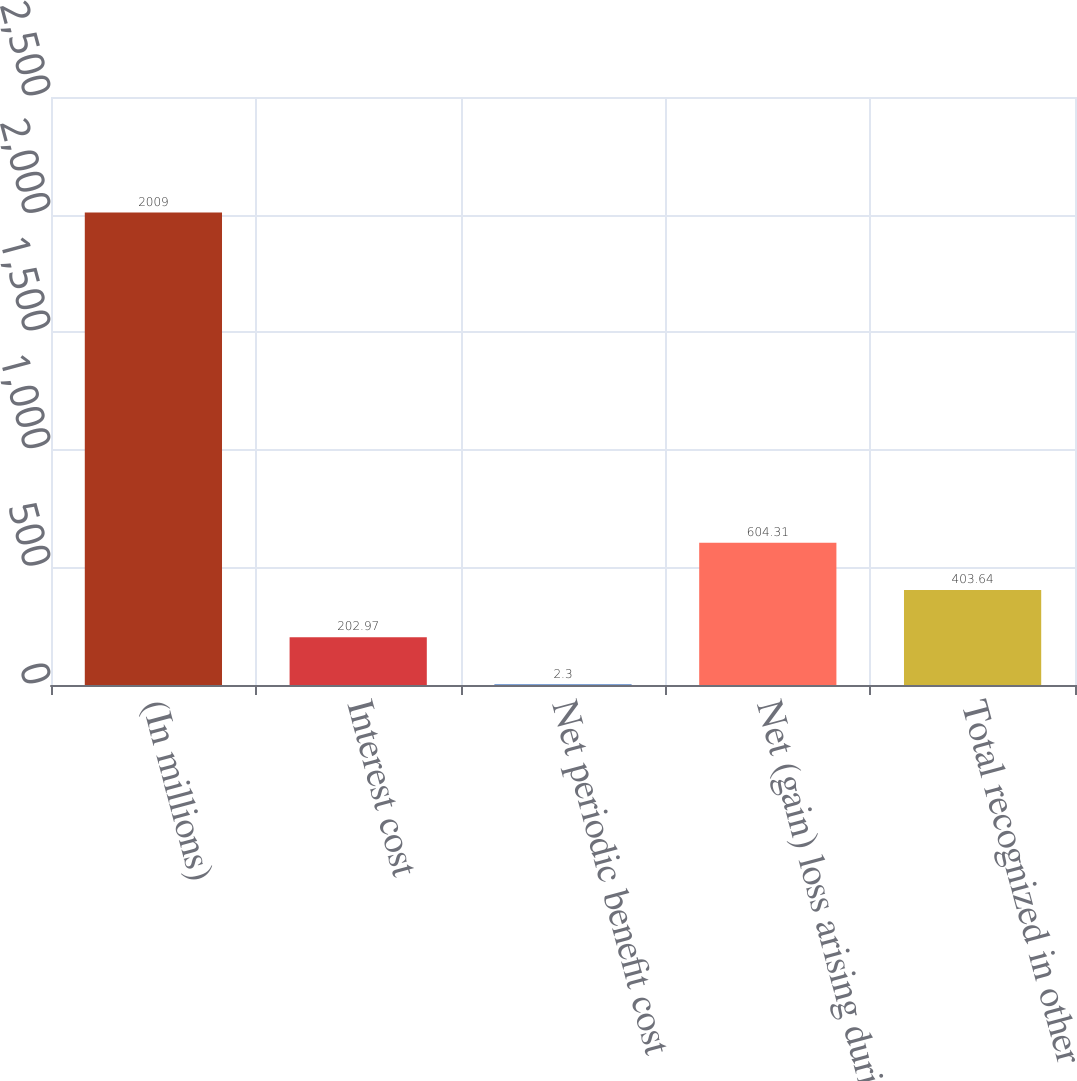Convert chart to OTSL. <chart><loc_0><loc_0><loc_500><loc_500><bar_chart><fcel>(In millions)<fcel>Interest cost<fcel>Net periodic benefit cost<fcel>Net (gain) loss arising during<fcel>Total recognized in other<nl><fcel>2009<fcel>202.97<fcel>2.3<fcel>604.31<fcel>403.64<nl></chart> 